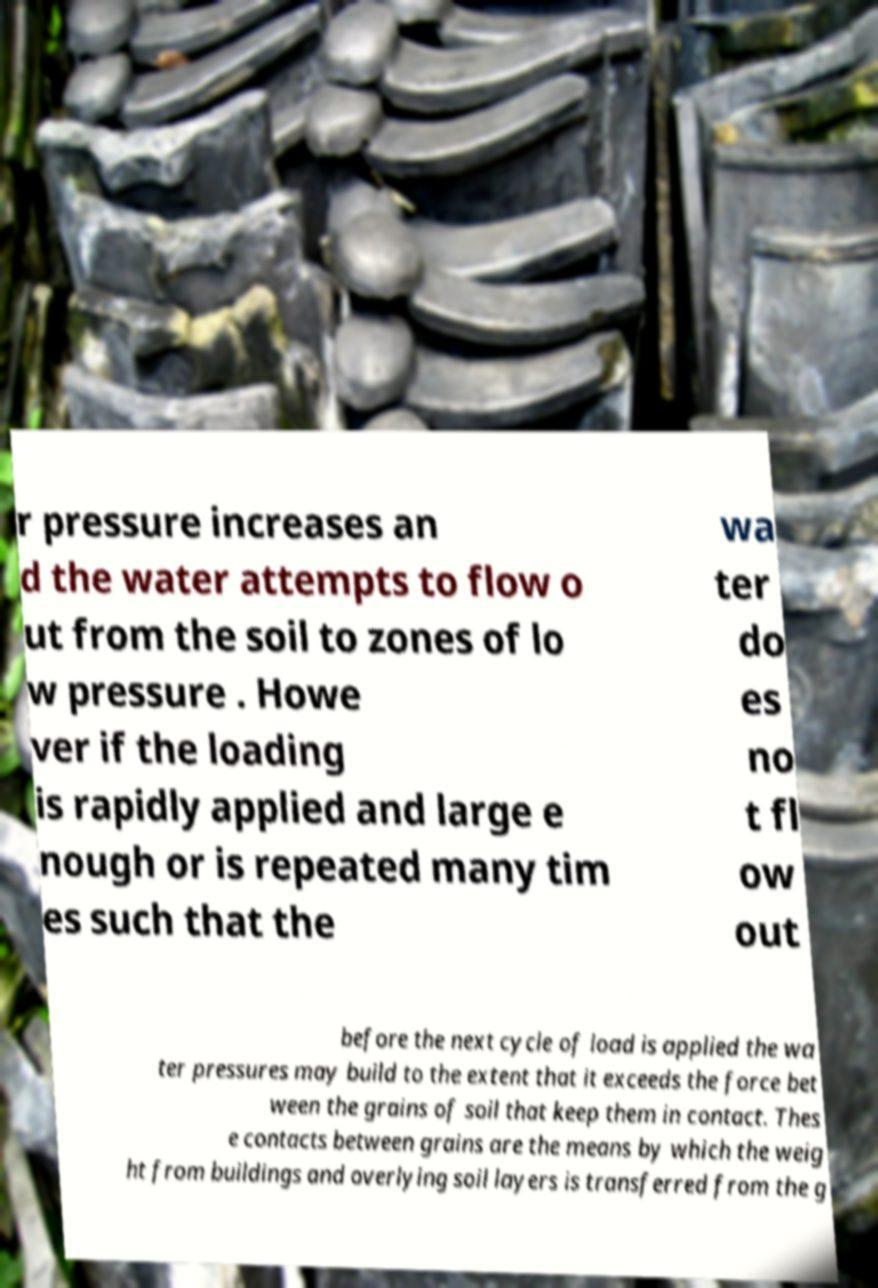There's text embedded in this image that I need extracted. Can you transcribe it verbatim? r pressure increases an d the water attempts to flow o ut from the soil to zones of lo w pressure . Howe ver if the loading is rapidly applied and large e nough or is repeated many tim es such that the wa ter do es no t fl ow out before the next cycle of load is applied the wa ter pressures may build to the extent that it exceeds the force bet ween the grains of soil that keep them in contact. Thes e contacts between grains are the means by which the weig ht from buildings and overlying soil layers is transferred from the g 